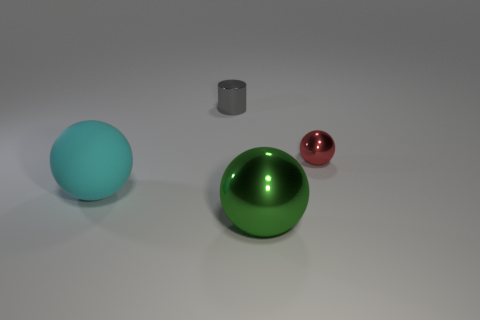What color is the tiny thing that is the same shape as the big cyan rubber thing?
Your answer should be compact. Red. Is there anything else that is the same shape as the gray thing?
Keep it short and to the point. No. There is a large sphere behind the green shiny sphere; what is its material?
Your answer should be very brief. Rubber. The red metal thing that is the same shape as the green shiny thing is what size?
Offer a terse response. Small. How many things have the same material as the large green sphere?
Offer a very short reply. 2. What number of rubber spheres are the same color as the tiny shiny sphere?
Your answer should be compact. 0. What number of things are large balls that are on the right side of the large cyan matte object or shiny objects that are behind the green thing?
Your response must be concise. 3. Is the number of big cyan rubber things that are to the right of the red ball less than the number of large metallic cubes?
Offer a very short reply. No. Is there a metallic sphere that has the same size as the gray object?
Provide a succinct answer. Yes. The big rubber thing has what color?
Your response must be concise. Cyan. 